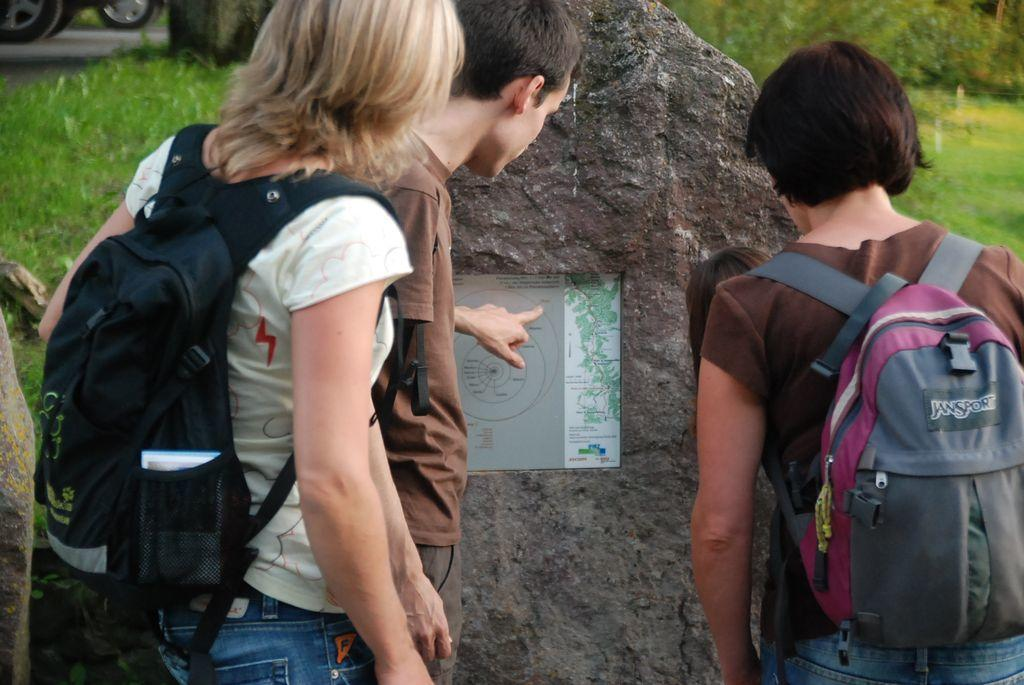<image>
Write a terse but informative summary of the picture. people with backpacks like Jansport looking at a map 